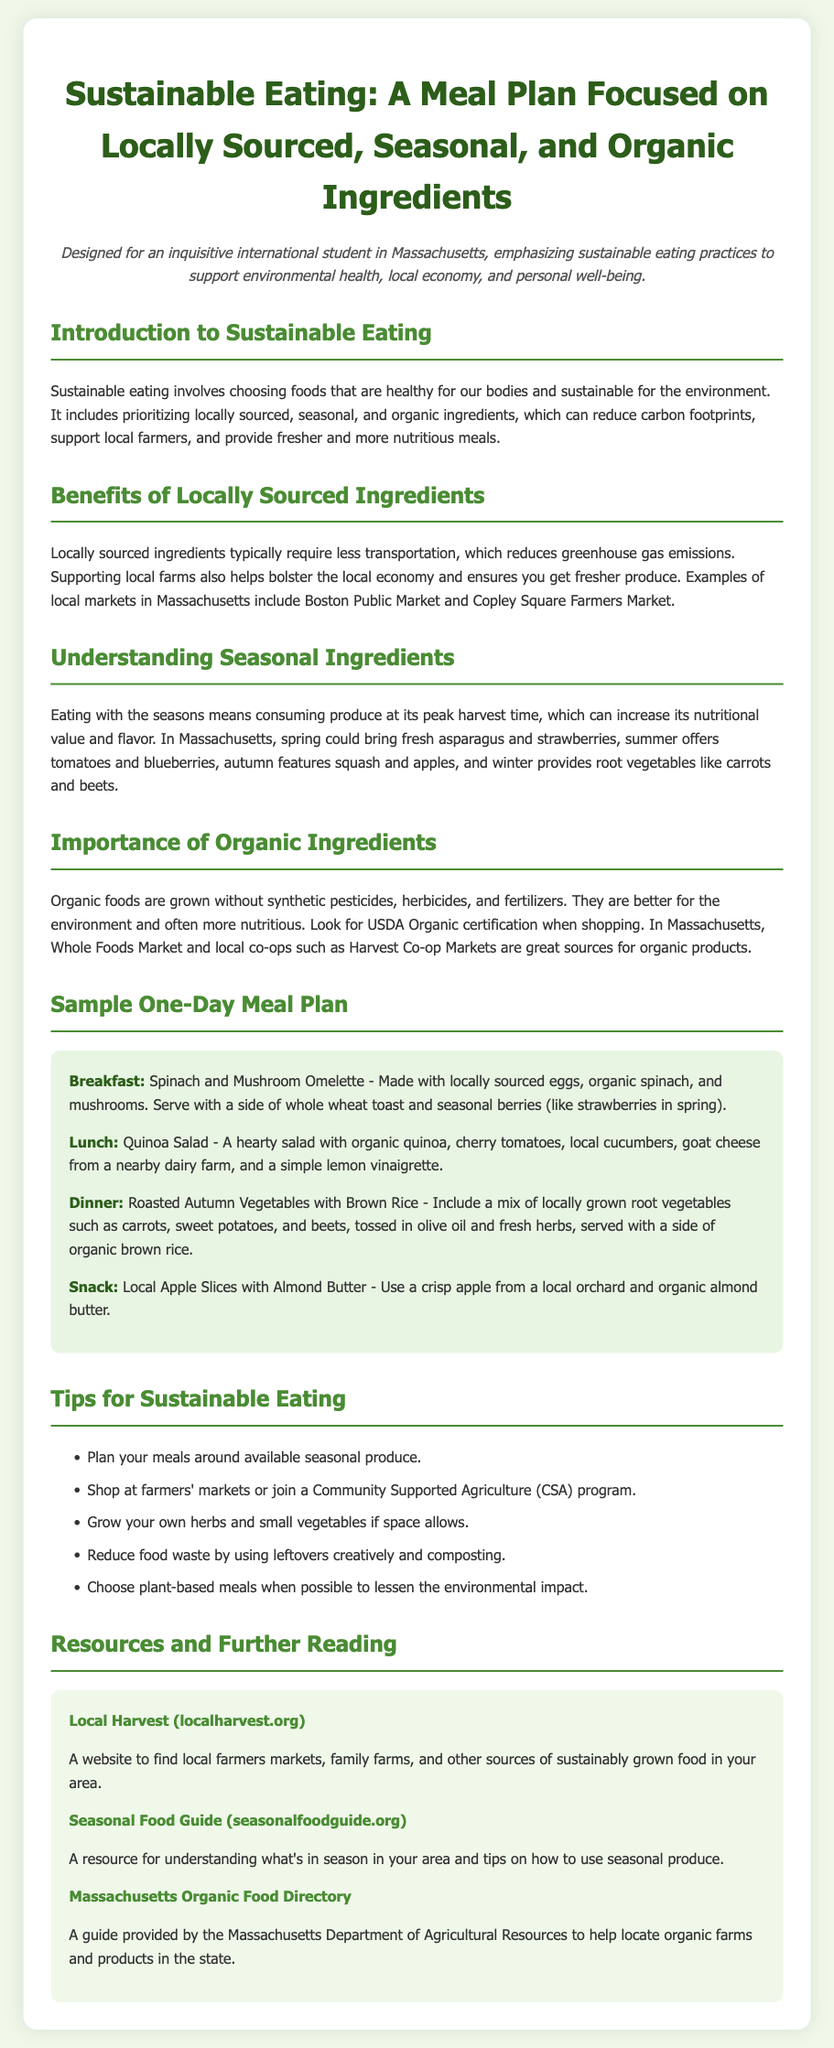What are the benefits of locally sourced ingredients? The document states that locally sourced ingredients typically require less transportation, reduce greenhouse gas emissions, bolster the local economy, and provide fresher produce.
Answer: Reduce transportation, greenhouse gas emissions, bolster local economy, fresher produce What can be found in Massachusetts during spring? The document lists that spring could bring fresh asparagus and strawberries.
Answer: Asparagus, strawberries What should you look for when shopping for organic products? According to the document, one should look for USDA Organic certification when shopping for organic products.
Answer: USDA Organic certification What is included in the sample breakfast? The breakfast consists of spinach and mushroom omelette made with locally sourced eggs, organic spinach, and mushrooms, served with toast and seasonal berries.
Answer: Spinach and mushroom omelette, whole wheat toast, seasonal berries Which resource helps locate organic farms in Massachusetts? The document mentions the Massachusetts Organic Food Directory as a guide to help locate organic farms and products in the state.
Answer: Massachusetts Organic Food Directory How can you reduce food waste according to the meal plan? The document suggests reducing food waste by using leftovers creatively and composting.
Answer: Use leftovers creatively and composting What is the main focus of the meal plan? The meal plan focuses on sustainable eating with locally sourced, seasonal, and organic ingredients.
Answer: Sustainable eating with locally sourced, seasonal, and organic ingredients What snack is recommended in the sample one-day meal plan? The snack recommended is local apple slices with almond butter.
Answer: Local apple slices with almond butter What does seasonal eating mean? Seasonal eating means consuming produce at its peak harvest time for better nutritional value and flavor.
Answer: Consuming produce at its peak harvest time 